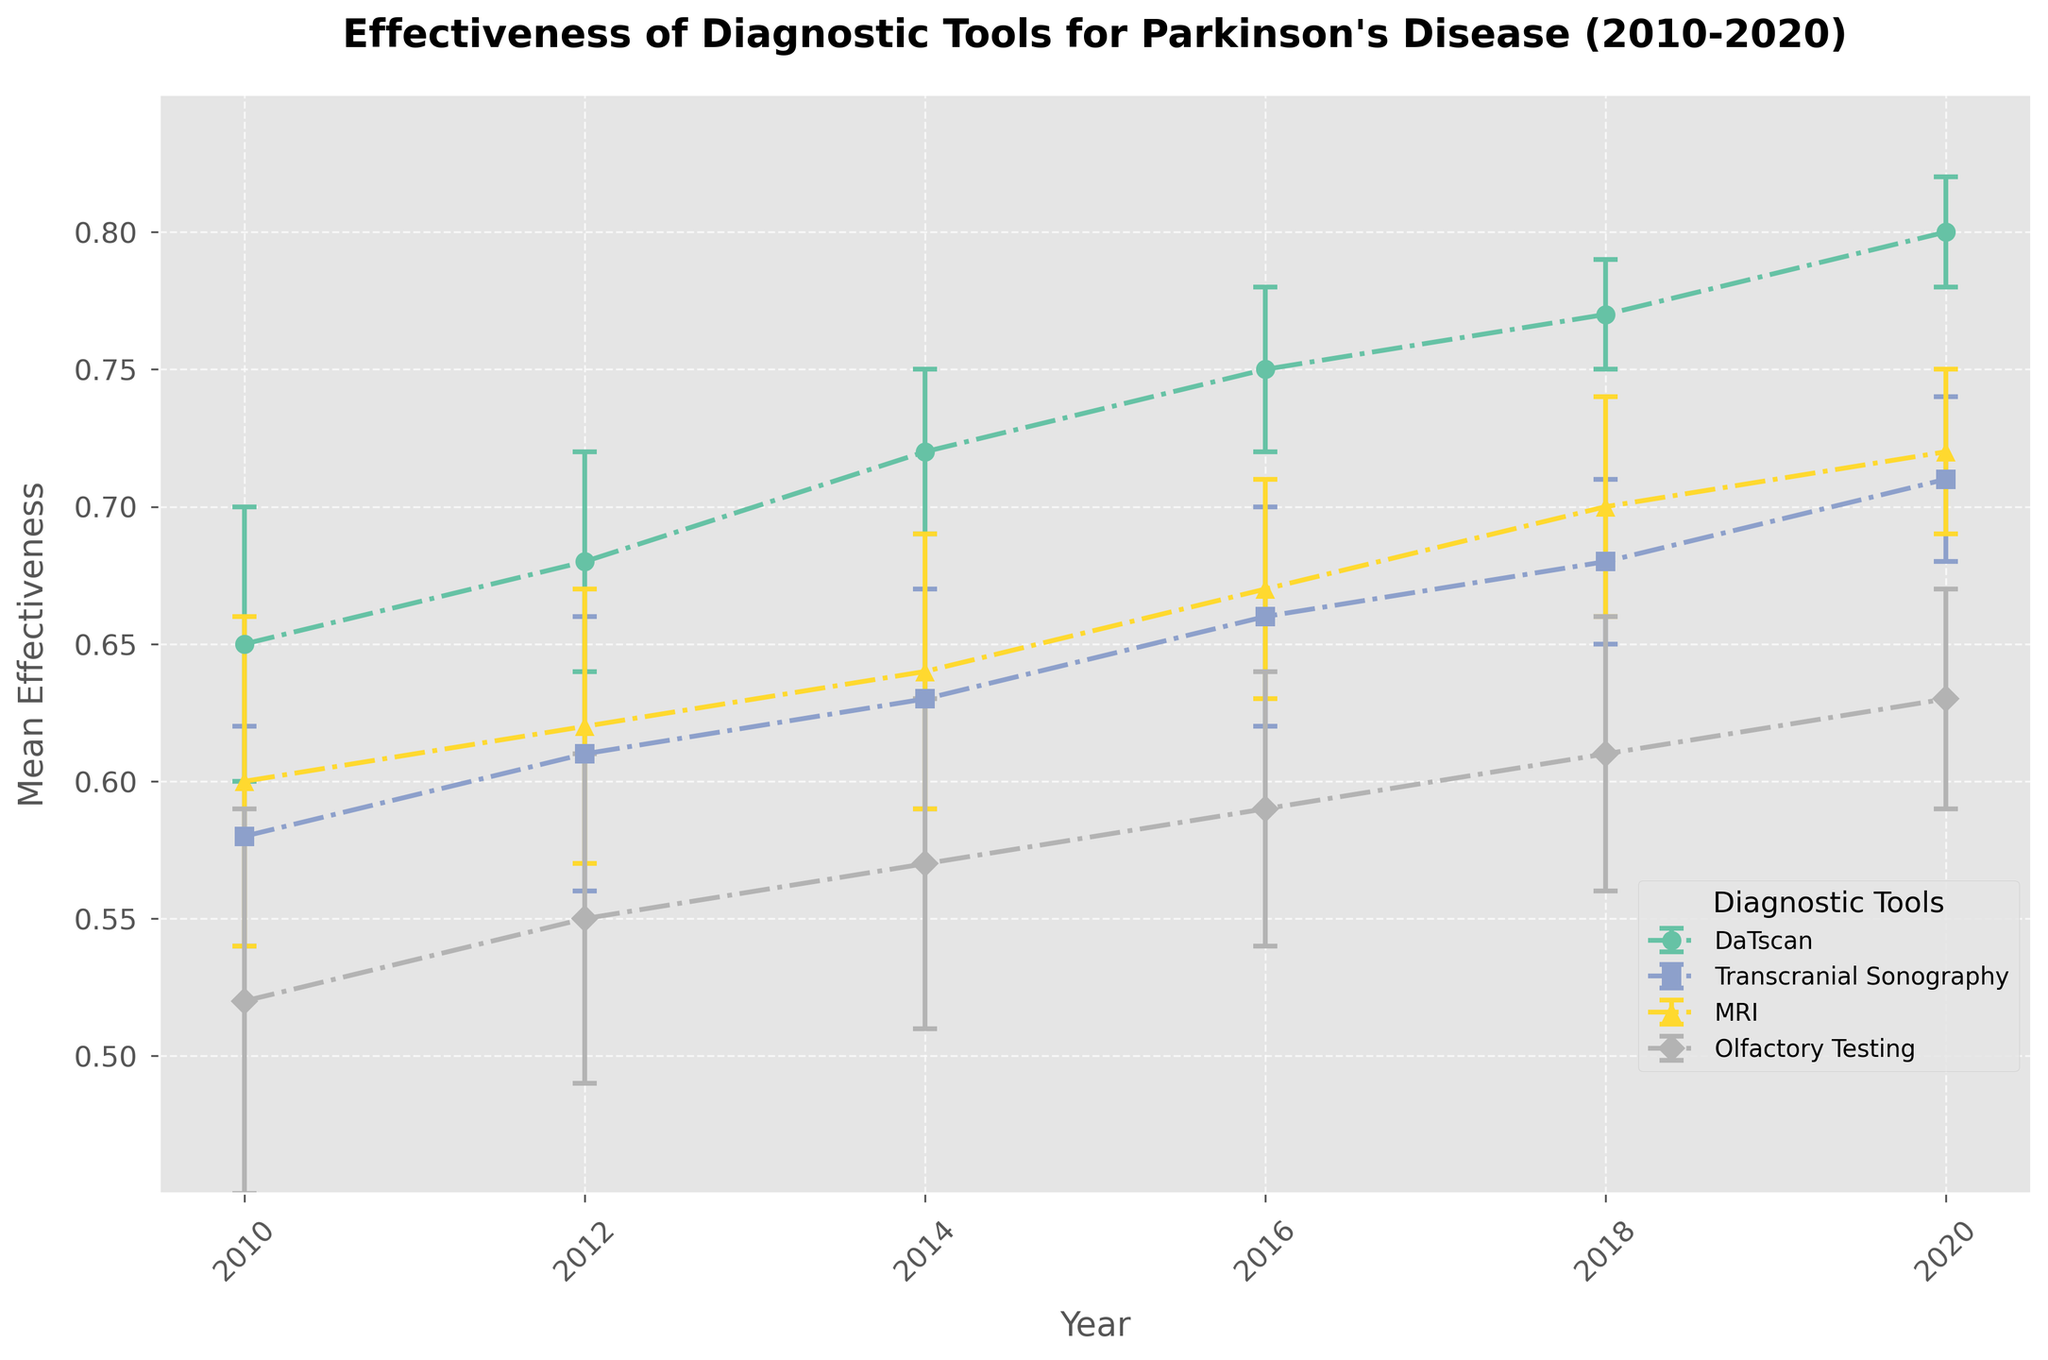What's the title of the figure? The title of the figure is prominently displayed at the top of the plot.
Answer: Effectiveness of Diagnostic Tools for Parkinson's Disease (2010-2020) How many different diagnostic tools are compared in the figure? The legend of the plot lists all the diagnostic tools compared.
Answer: Four Which diagnostic tool had the highest mean effectiveness in 2020? Locate the data points for 2020 and compare the mean effectiveness values.
Answer: DaTscan What was the mean effectiveness of MRI in 2016? Find the data points for MRI in 2016 on the plot and read the mean effectiveness value.
Answer: 0.67 Which diagnostic tool showed the greatest improvement in mean effectiveness from 2010 to 2020? Compare the mean effectiveness values of each diagnostic tool from 2010 to 2020 and calculate the differences.
Answer: DaTscan What is the difference in mean effectiveness between DaTscan and Olfactory Testing in 2020? Find the data points for DaTscan and Olfactory Testing in 2020 and subtract the effectiveness values.
Answer: 0.17 Which diagnostic tool had the smallest standard deviation in 2018? Locate the error bars for each tool in 2018 and compare their lengths.
Answer: DaTscan What trend do you observe for the effectiveness of Transcranial Sonography over the decade? Observe the changes in the mean effectiveness values for Transcranial Sonography from 2010 to 2020.
Answer: Increasing Did the effectiveness of Olfactory Testing exceed 0.60 at any point during the decade? Compare the mean effectiveness values of Olfactory Testing in each year to 0.60.
Answer: No What is the average effectiveness of DaTscan from 2010 to 2020? Add the mean effectiveness values of DaTscan for each year and divide by the number of years.
Answer: 0.728 